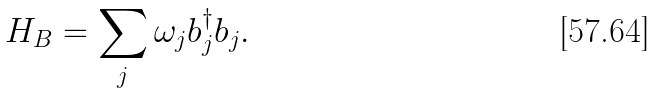Convert formula to latex. <formula><loc_0><loc_0><loc_500><loc_500>H _ { B } = \sum _ { j } \omega _ { j } b _ { j } ^ { \dagger } b _ { j } .</formula> 